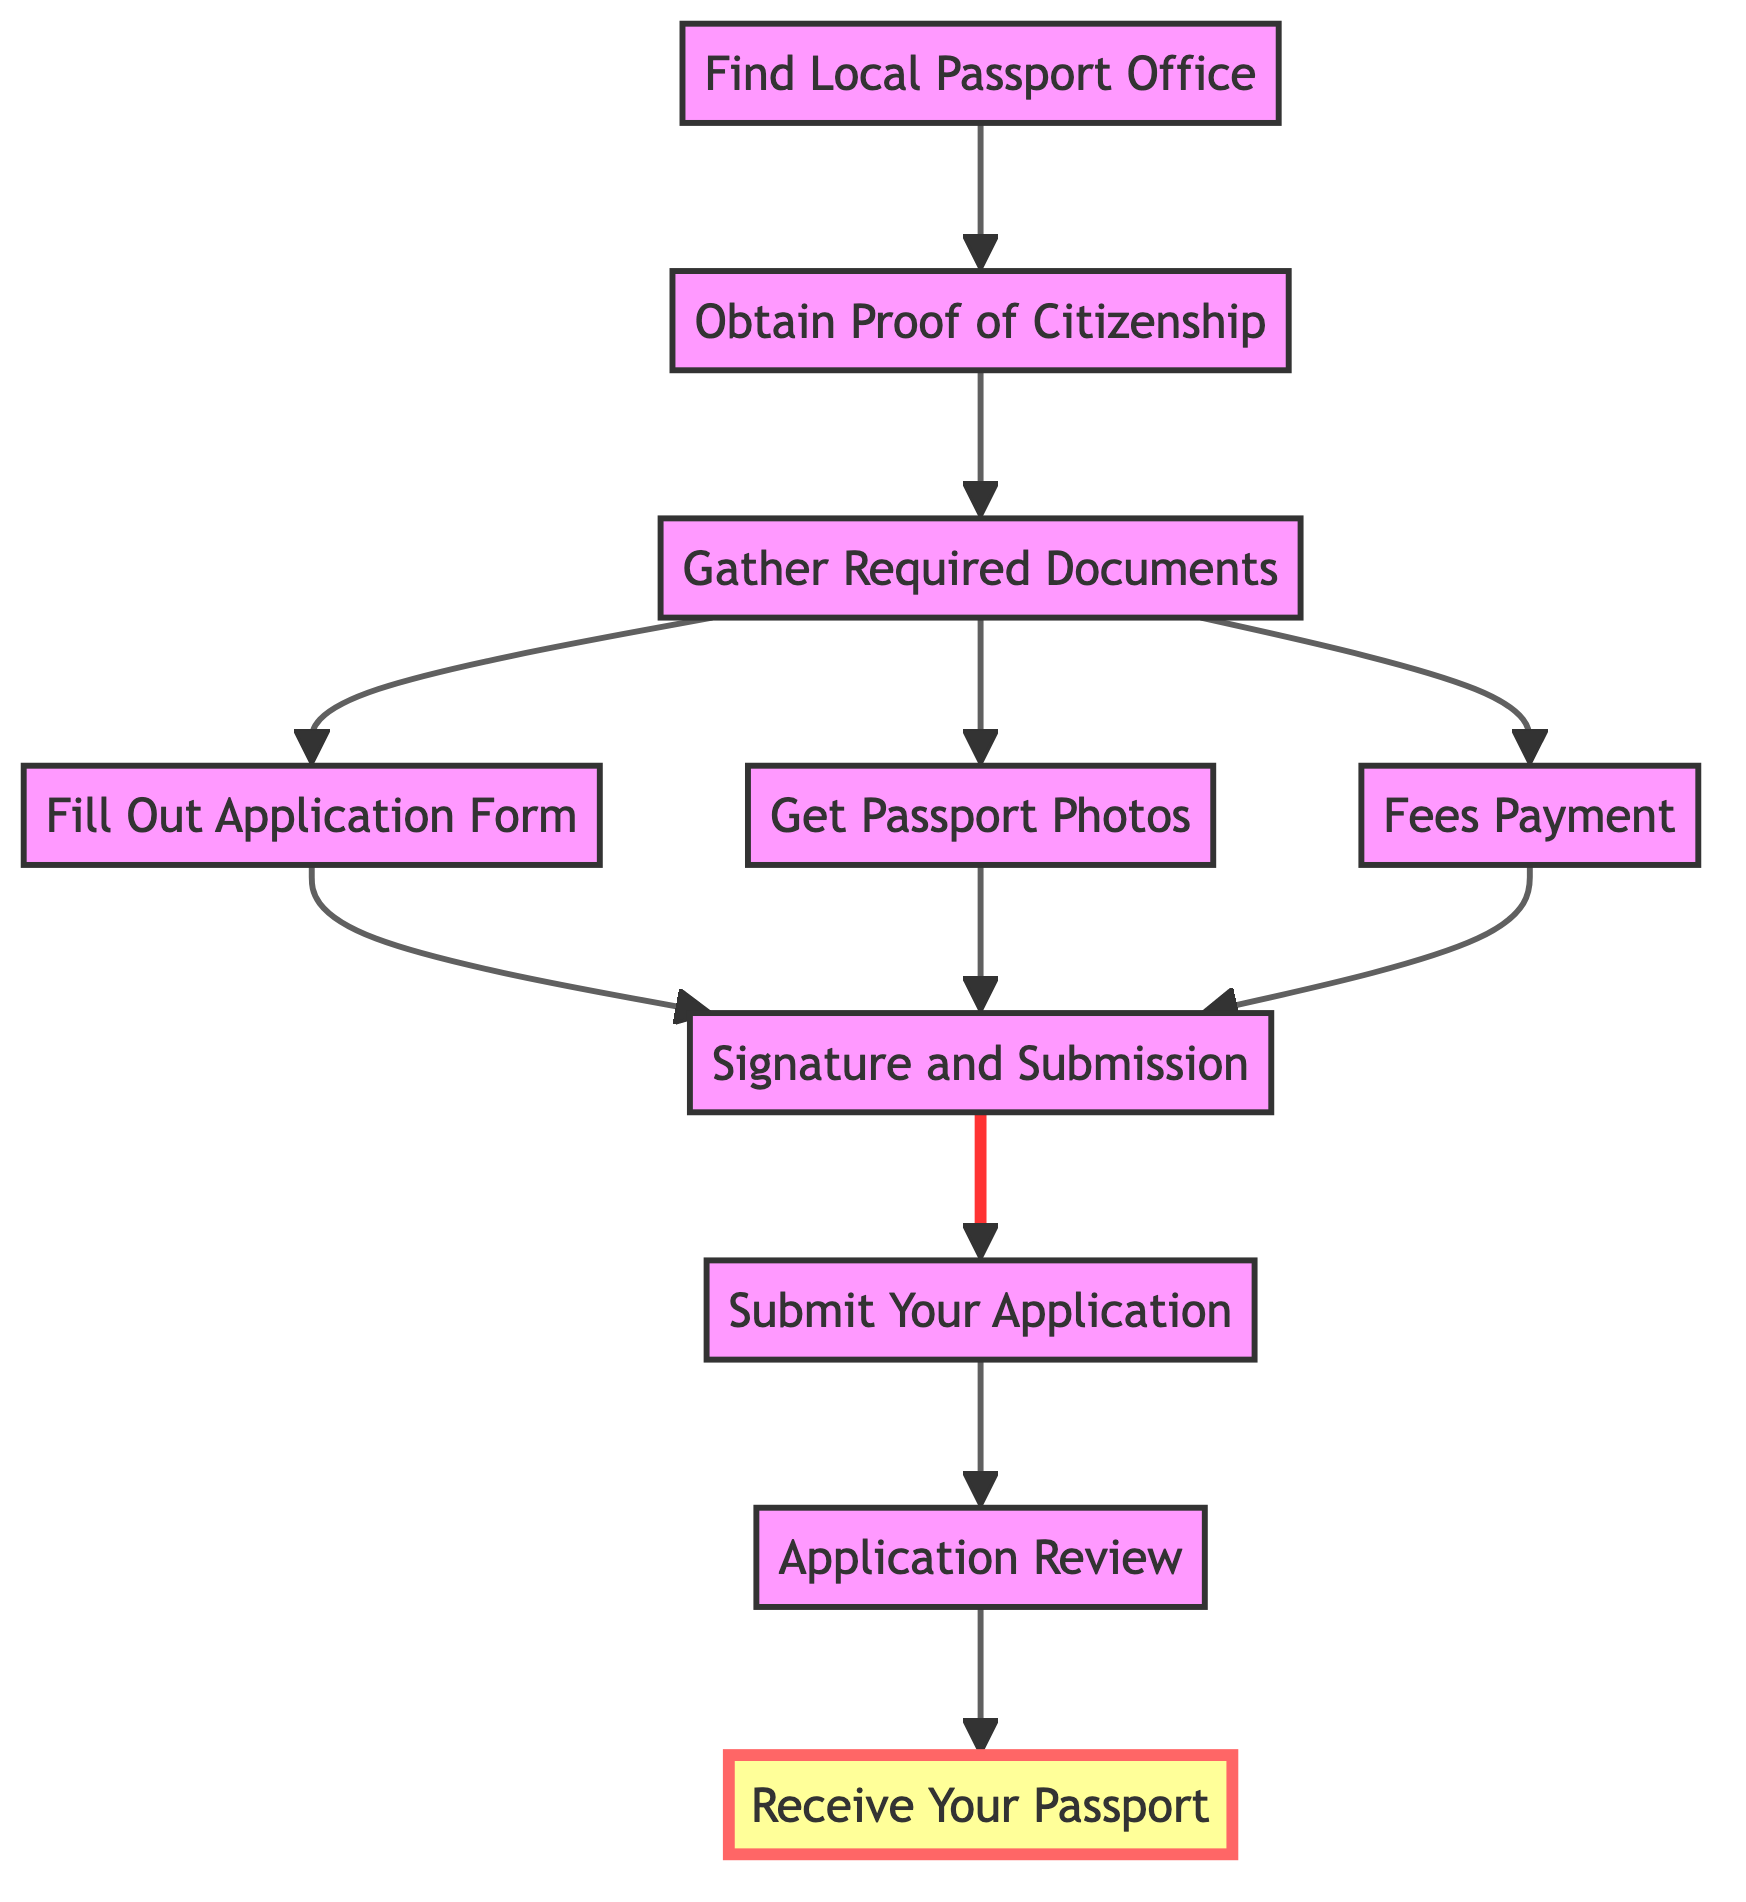What is the last step in the process? The last step in the flowchart is labeled "Receive Your Passport," which is the final action that occurs after all previous steps have been completed.
Answer: Receive Your Passport How many total steps are in the diagram? The diagram includes 10 distinct steps, each representing a different part of the process to obtain a passport.
Answer: 10 What do you need before filling out the application form? Before filling out the application form, one needs to gather required documents, which are prerequisites for completing the application.
Answer: Gather Required Documents What is the step before submitting your application? The step before submitting your application is "Signature and Submission," where the application form is signed and prepared for submission.
Answer: Signature and Submission Which step requires obtaining a birth certificate? The step that specifically involves obtaining a birth certificate falls under "Obtain Proof of Citizenship," which is necessary to ensure proof of identity and nationality.
Answer: Obtain Proof of Citizenship Which two steps must be completed before "Signature and Submission"? "Fill Out Application Form" and "Get Passport Photos" both need to be finished before reaching the "Signature and Submission" step, as they are part of the necessary requirements.
Answer: Fill Out Application Form and Get Passport Photos What step comes right after "Application Review"? The step that directly follows "Application Review" is "Receive Your Passport," indicating what happens once the application has been processed and approved.
Answer: Receive Your Passport What is the primary action of the "Fees Payment" step? The primary action in the "Fees Payment" step is to prepare for paying the application fee, which is a necessary financial requirement for processing the passport application.
Answer: Prepare to pay the passport application fee Where can you find your nearest passport office? You can locate your nearest passport office by checking the official government website, which provides information on accessible services for submitting passport applications.
Answer: Official government website 